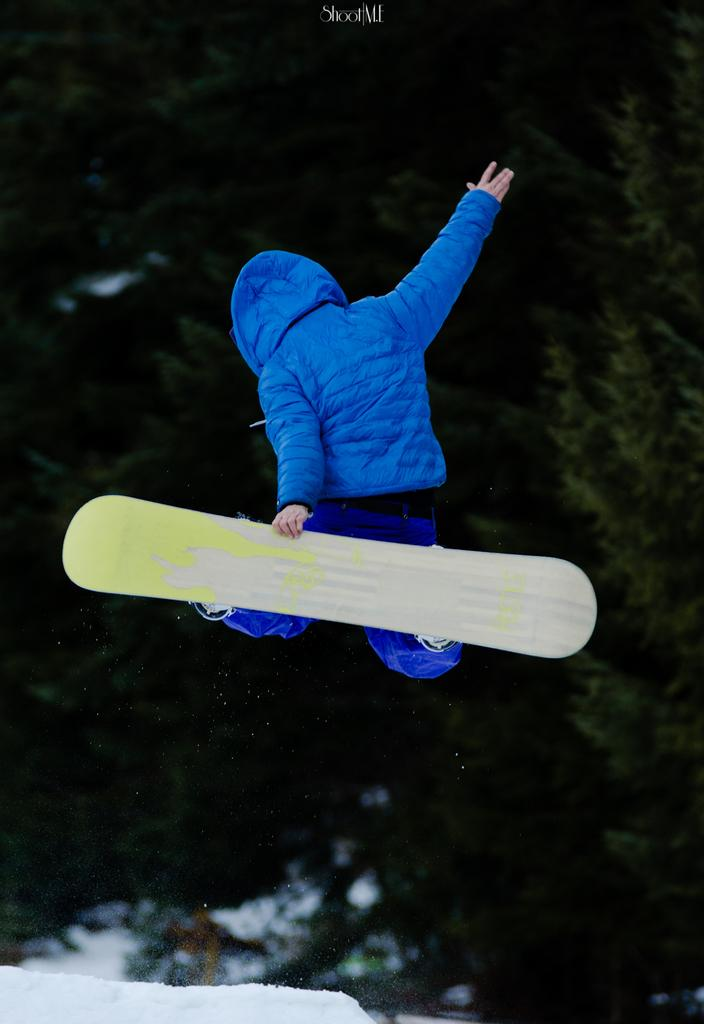Who is the person in the image? There is a man in the image. What is the man wearing? The man is wearing a blue jacket and blue pants. What activity is the man engaged in? The man is performing skating stunts. What is the weather like in the image? There is snow on the ground in the image, indicating a cold and likely snowy environment. What can be seen in the background of the image? There are trees in the background of the image. How does the man use glue in the image? There is no glue present in the image, and therefore no such activity can be observed. Is the man performing the skating stunts in a quiet environment? The image does not provide information about the noise level in the environment, so it cannot be determined whether it is quiet or not. 